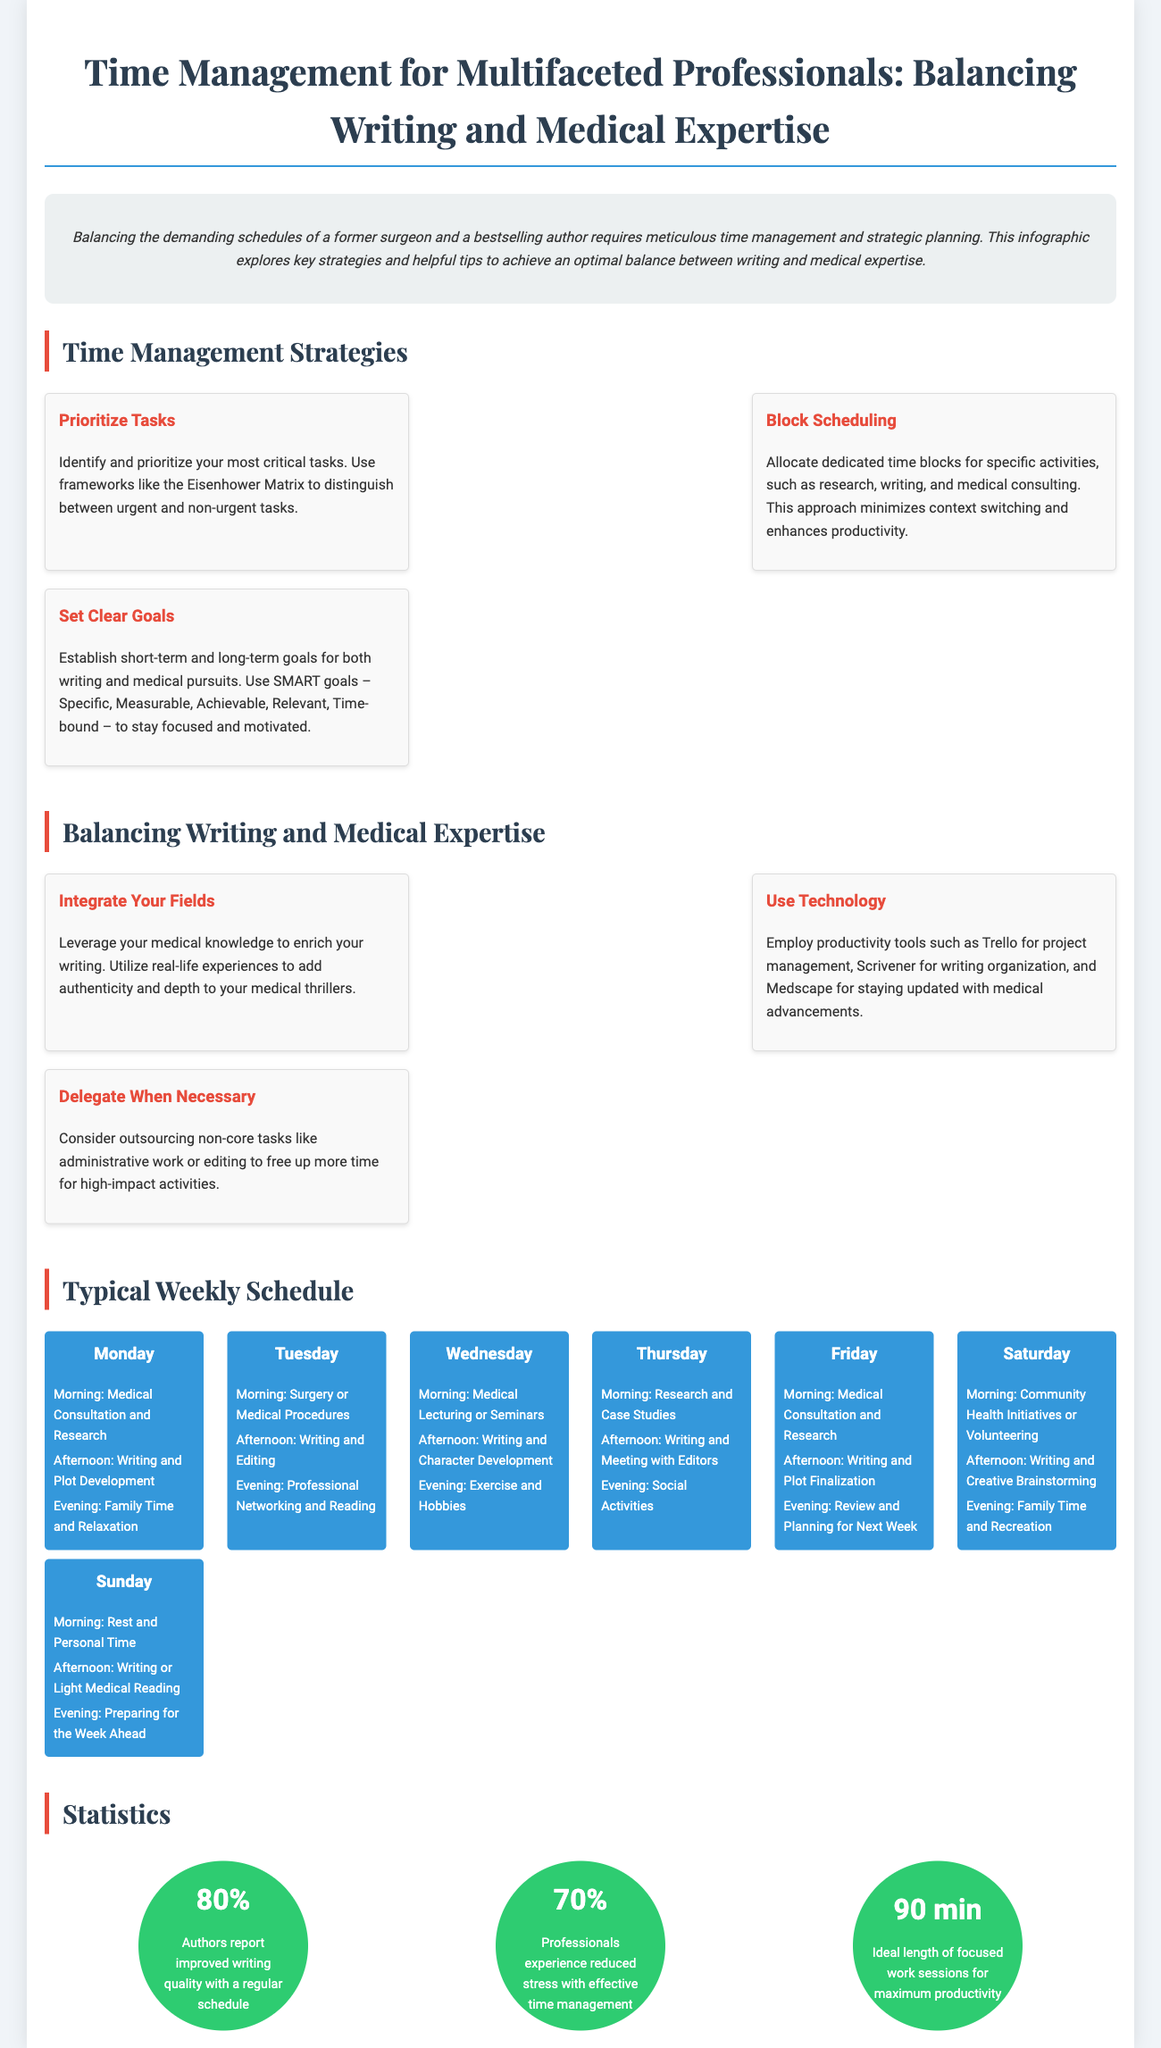What is the purpose of the infographic? The infographic aims to explore key strategies and helpful tips to achieve an optimal balance between writing and medical expertise.
Answer: Time Management What is one strategy recommended for time management? One of the strategies is to identify and prioritize your most critical tasks using frameworks like the Eisenhower Matrix.
Answer: Prioritize Tasks What percentage of authors report improved writing quality with a regular schedule? The infographic states that 80% of authors report this improvement.
Answer: 80% What technology tools are suggested for productivity? The infographic suggests using Trello, Scrivener, and Medscape for productivity and organization.
Answer: Trello, Scrivener, Medscape What is the ideal length of focused work sessions for maximum productivity? The infographic specifies that 90 minutes is the ideal length of focused work sessions.
Answer: 90 min What activity is planned for Saturday mornings? The schedule indicates that community health initiatives or volunteering is planned for that time.
Answer: Community Health Initiatives What goal-setting method is recommended in the strategies? The infographic recommends using SMART goals for establishing objectives.
Answer: SMART goals How do professionals feel about effective time management according to the infographic? It states that 70% of professionals experience reduced stress with effective time management.
Answer: Reduced stress 